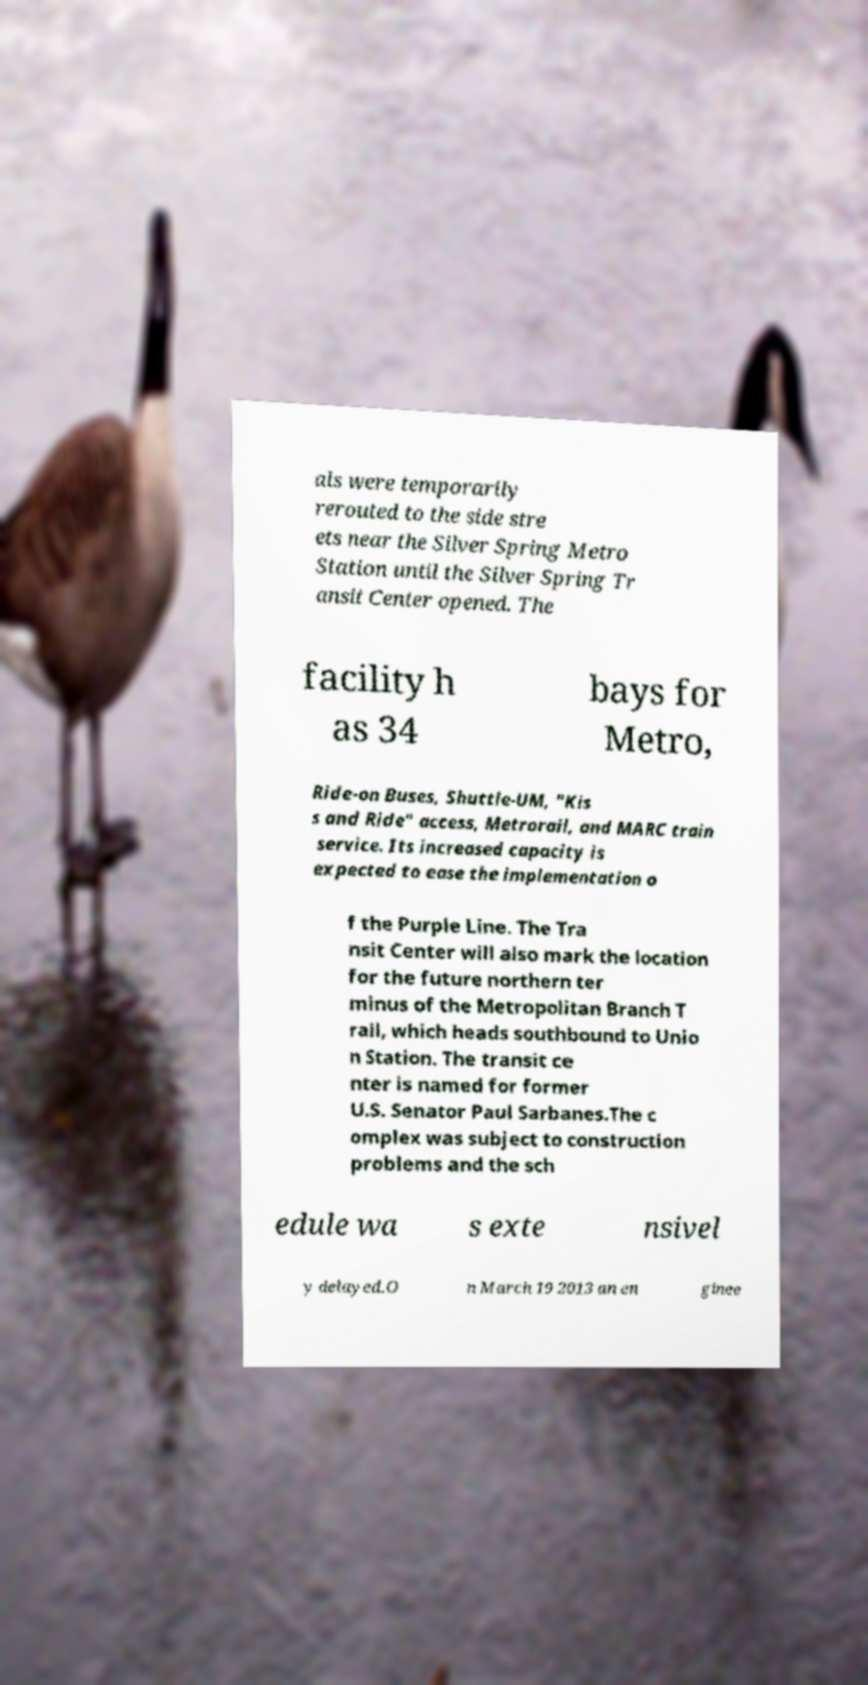What messages or text are displayed in this image? I need them in a readable, typed format. als were temporarily rerouted to the side stre ets near the Silver Spring Metro Station until the Silver Spring Tr ansit Center opened. The facility h as 34 bays for Metro, Ride-on Buses, Shuttle-UM, "Kis s and Ride" access, Metrorail, and MARC train service. Its increased capacity is expected to ease the implementation o f the Purple Line. The Tra nsit Center will also mark the location for the future northern ter minus of the Metropolitan Branch T rail, which heads southbound to Unio n Station. The transit ce nter is named for former U.S. Senator Paul Sarbanes.The c omplex was subject to construction problems and the sch edule wa s exte nsivel y delayed.O n March 19 2013 an en ginee 